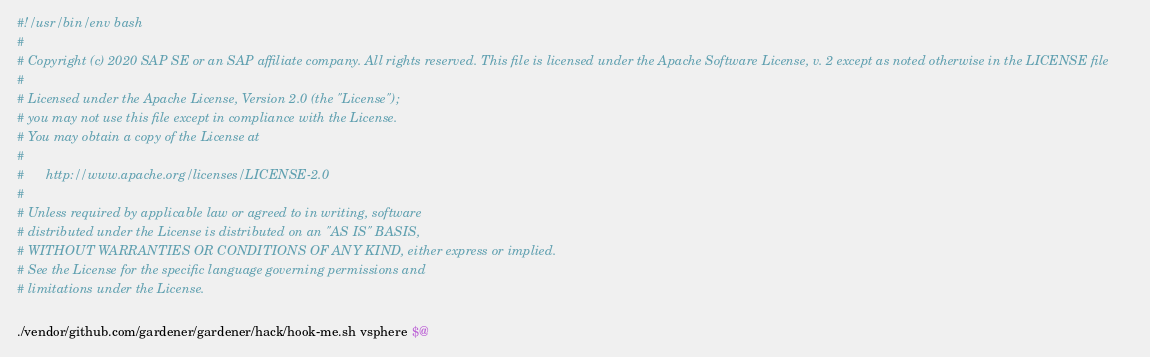Convert code to text. <code><loc_0><loc_0><loc_500><loc_500><_Bash_>#!/usr/bin/env bash
#
# Copyright (c) 2020 SAP SE or an SAP affiliate company. All rights reserved. This file is licensed under the Apache Software License, v. 2 except as noted otherwise in the LICENSE file
#
# Licensed under the Apache License, Version 2.0 (the "License");
# you may not use this file except in compliance with the License.
# You may obtain a copy of the License at
#
#      http://www.apache.org/licenses/LICENSE-2.0
#
# Unless required by applicable law or agreed to in writing, software
# distributed under the License is distributed on an "AS IS" BASIS,
# WITHOUT WARRANTIES OR CONDITIONS OF ANY KIND, either express or implied.
# See the License for the specific language governing permissions and
# limitations under the License.

./vendor/github.com/gardener/gardener/hack/hook-me.sh vsphere $@
</code> 